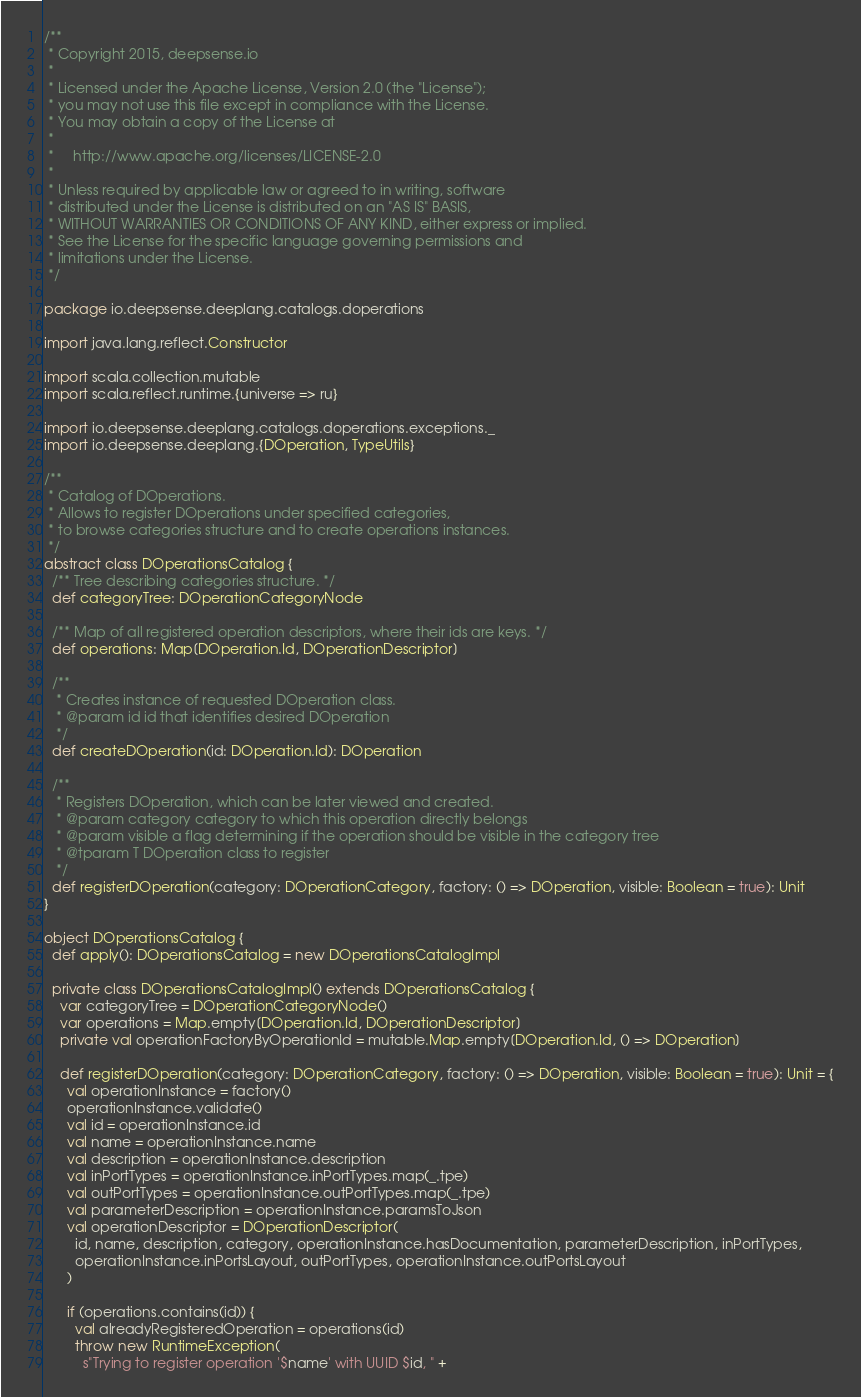<code> <loc_0><loc_0><loc_500><loc_500><_Scala_>/**
 * Copyright 2015, deepsense.io
 *
 * Licensed under the Apache License, Version 2.0 (the "License");
 * you may not use this file except in compliance with the License.
 * You may obtain a copy of the License at
 *
 *     http://www.apache.org/licenses/LICENSE-2.0
 *
 * Unless required by applicable law or agreed to in writing, software
 * distributed under the License is distributed on an "AS IS" BASIS,
 * WITHOUT WARRANTIES OR CONDITIONS OF ANY KIND, either express or implied.
 * See the License for the specific language governing permissions and
 * limitations under the License.
 */

package io.deepsense.deeplang.catalogs.doperations

import java.lang.reflect.Constructor

import scala.collection.mutable
import scala.reflect.runtime.{universe => ru}

import io.deepsense.deeplang.catalogs.doperations.exceptions._
import io.deepsense.deeplang.{DOperation, TypeUtils}

/**
 * Catalog of DOperations.
 * Allows to register DOperations under specified categories,
 * to browse categories structure and to create operations instances.
 */
abstract class DOperationsCatalog {
  /** Tree describing categories structure. */
  def categoryTree: DOperationCategoryNode

  /** Map of all registered operation descriptors, where their ids are keys. */
  def operations: Map[DOperation.Id, DOperationDescriptor]

  /**
   * Creates instance of requested DOperation class.
   * @param id id that identifies desired DOperation
   */
  def createDOperation(id: DOperation.Id): DOperation

  /**
   * Registers DOperation, which can be later viewed and created.
   * @param category category to which this operation directly belongs
   * @param visible a flag determining if the operation should be visible in the category tree
   * @tparam T DOperation class to register
   */
  def registerDOperation(category: DOperationCategory, factory: () => DOperation, visible: Boolean = true): Unit
}

object DOperationsCatalog {
  def apply(): DOperationsCatalog = new DOperationsCatalogImpl

  private class DOperationsCatalogImpl() extends DOperationsCatalog {
    var categoryTree = DOperationCategoryNode()
    var operations = Map.empty[DOperation.Id, DOperationDescriptor]
    private val operationFactoryByOperationId = mutable.Map.empty[DOperation.Id, () => DOperation]

    def registerDOperation(category: DOperationCategory, factory: () => DOperation, visible: Boolean = true): Unit = {
      val operationInstance = factory()
      operationInstance.validate()
      val id = operationInstance.id
      val name = operationInstance.name
      val description = operationInstance.description
      val inPortTypes = operationInstance.inPortTypes.map(_.tpe)
      val outPortTypes = operationInstance.outPortTypes.map(_.tpe)
      val parameterDescription = operationInstance.paramsToJson
      val operationDescriptor = DOperationDescriptor(
        id, name, description, category, operationInstance.hasDocumentation, parameterDescription, inPortTypes,
        operationInstance.inPortsLayout, outPortTypes, operationInstance.outPortsLayout
      )

      if (operations.contains(id)) {
        val alreadyRegisteredOperation = operations(id)
        throw new RuntimeException(
          s"Trying to register operation '$name' with UUID $id, " +</code> 